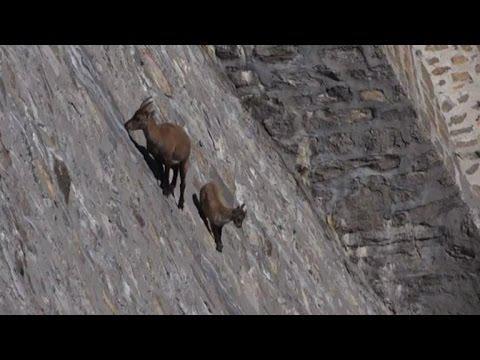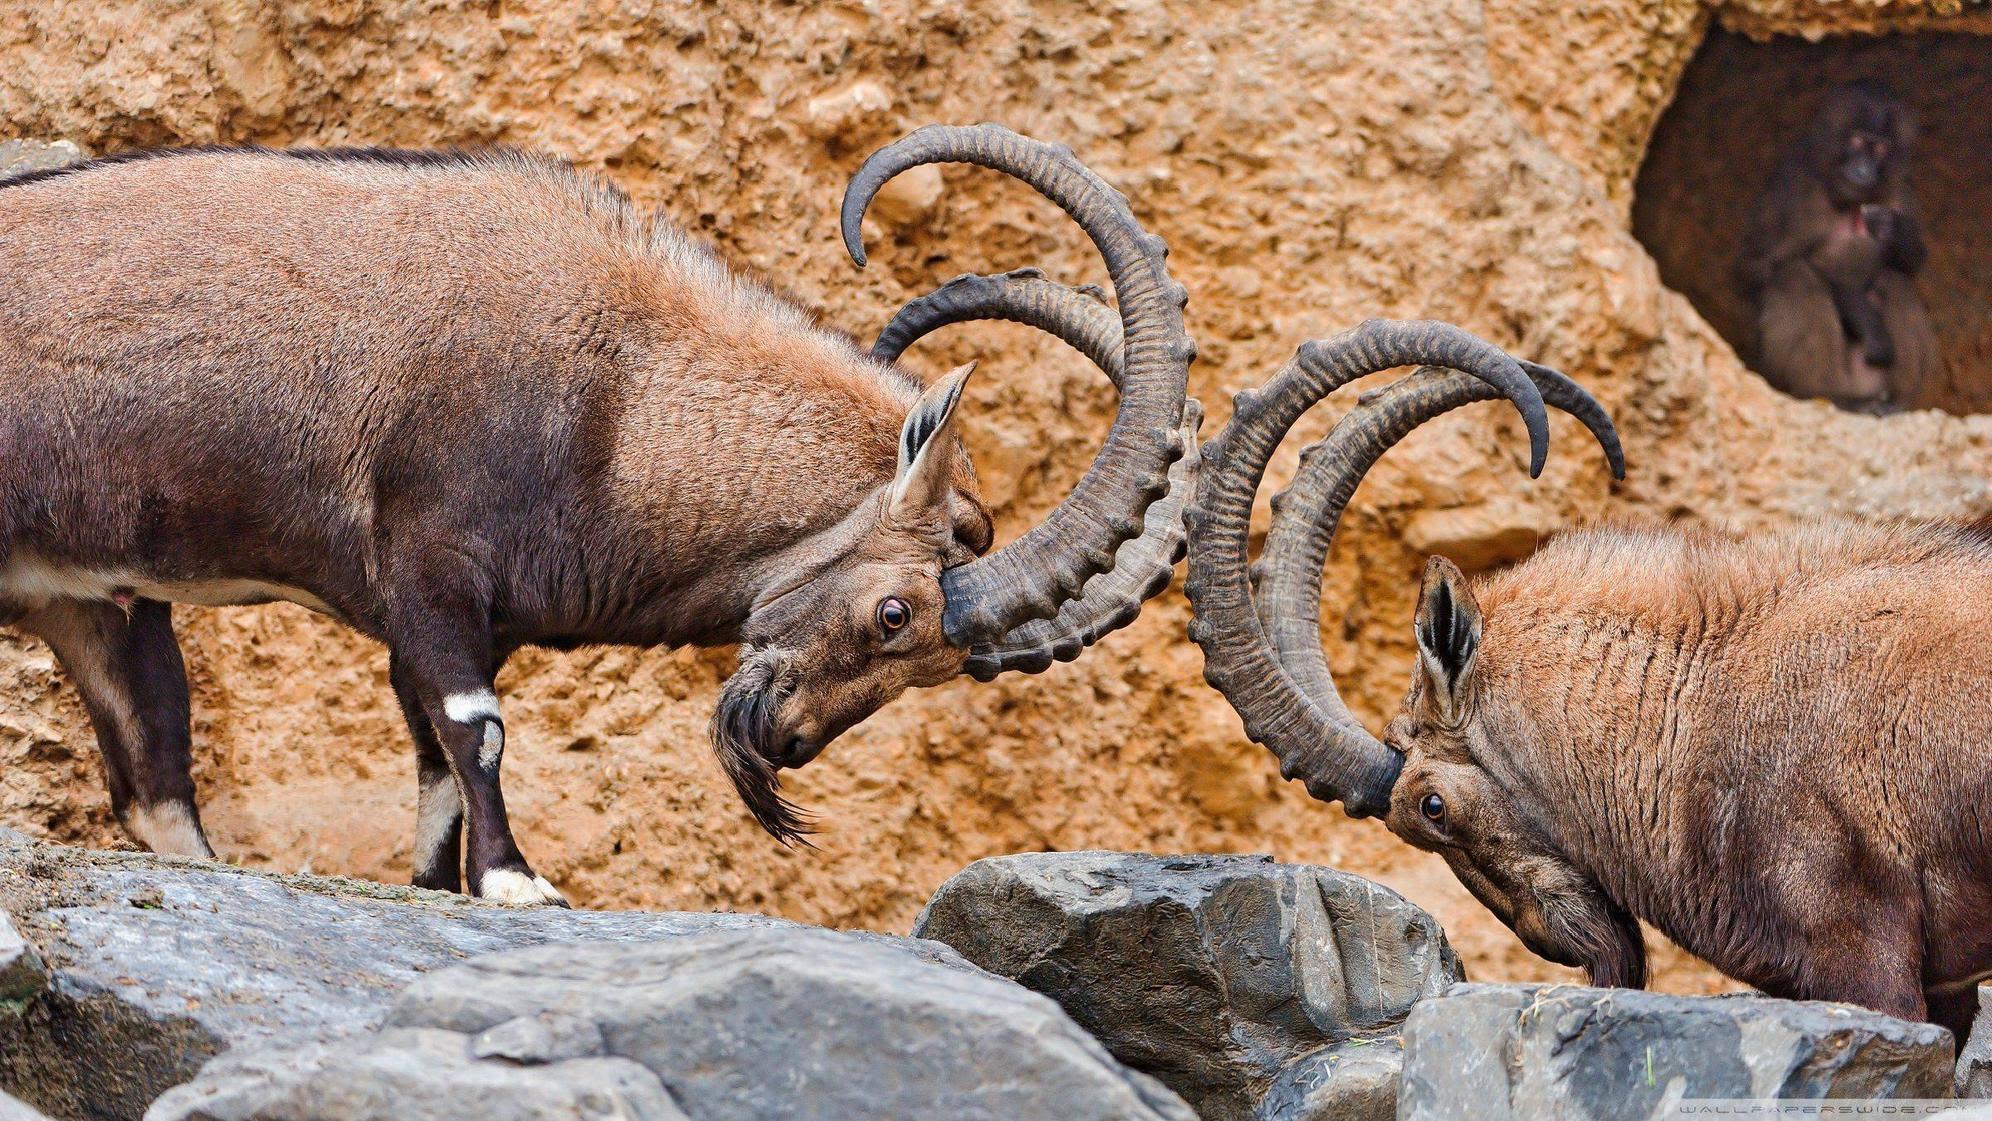The first image is the image on the left, the second image is the image on the right. Assess this claim about the two images: "There are goats balancing on a very very steep cliffside.". Correct or not? Answer yes or no. Yes. 